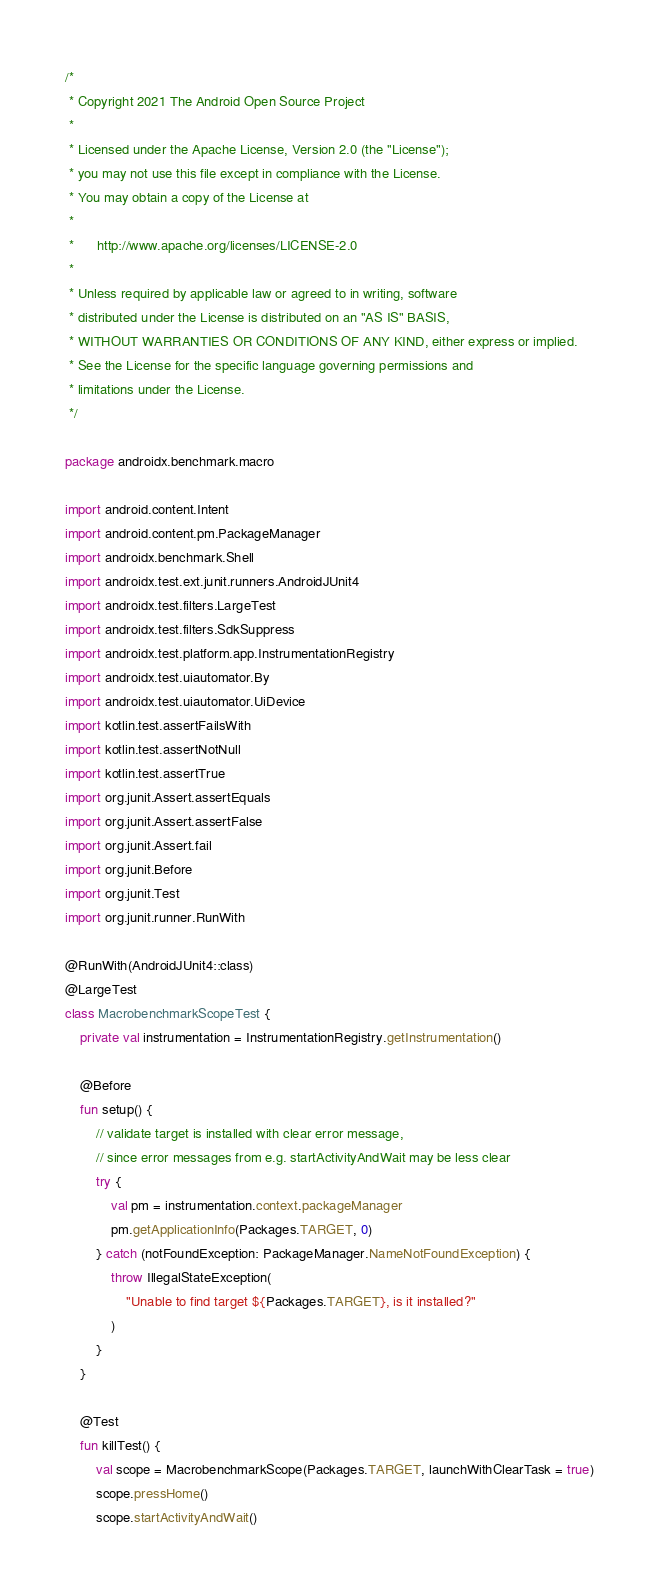<code> <loc_0><loc_0><loc_500><loc_500><_Kotlin_>/*
 * Copyright 2021 The Android Open Source Project
 *
 * Licensed under the Apache License, Version 2.0 (the "License");
 * you may not use this file except in compliance with the License.
 * You may obtain a copy of the License at
 *
 *      http://www.apache.org/licenses/LICENSE-2.0
 *
 * Unless required by applicable law or agreed to in writing, software
 * distributed under the License is distributed on an "AS IS" BASIS,
 * WITHOUT WARRANTIES OR CONDITIONS OF ANY KIND, either express or implied.
 * See the License for the specific language governing permissions and
 * limitations under the License.
 */

package androidx.benchmark.macro

import android.content.Intent
import android.content.pm.PackageManager
import androidx.benchmark.Shell
import androidx.test.ext.junit.runners.AndroidJUnit4
import androidx.test.filters.LargeTest
import androidx.test.filters.SdkSuppress
import androidx.test.platform.app.InstrumentationRegistry
import androidx.test.uiautomator.By
import androidx.test.uiautomator.UiDevice
import kotlin.test.assertFailsWith
import kotlin.test.assertNotNull
import kotlin.test.assertTrue
import org.junit.Assert.assertEquals
import org.junit.Assert.assertFalse
import org.junit.Assert.fail
import org.junit.Before
import org.junit.Test
import org.junit.runner.RunWith

@RunWith(AndroidJUnit4::class)
@LargeTest
class MacrobenchmarkScopeTest {
    private val instrumentation = InstrumentationRegistry.getInstrumentation()

    @Before
    fun setup() {
        // validate target is installed with clear error message,
        // since error messages from e.g. startActivityAndWait may be less clear
        try {
            val pm = instrumentation.context.packageManager
            pm.getApplicationInfo(Packages.TARGET, 0)
        } catch (notFoundException: PackageManager.NameNotFoundException) {
            throw IllegalStateException(
                "Unable to find target ${Packages.TARGET}, is it installed?"
            )
        }
    }

    @Test
    fun killTest() {
        val scope = MacrobenchmarkScope(Packages.TARGET, launchWithClearTask = true)
        scope.pressHome()
        scope.startActivityAndWait()</code> 